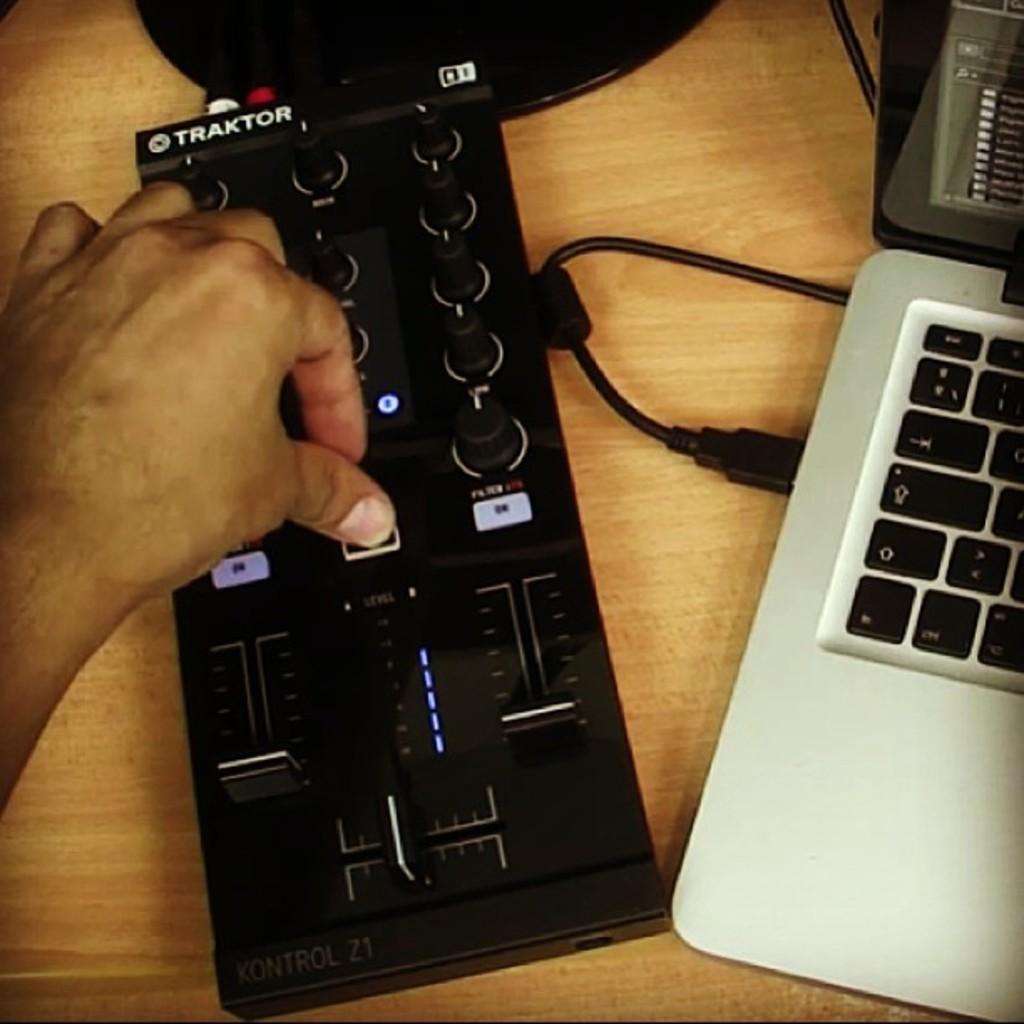Who makes this sound mixer?
Offer a terse response. Traktor. What is model of the mixer?
Offer a terse response. Traktor. 